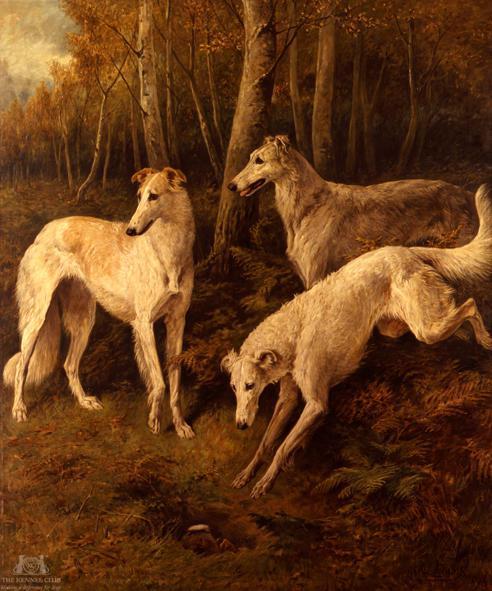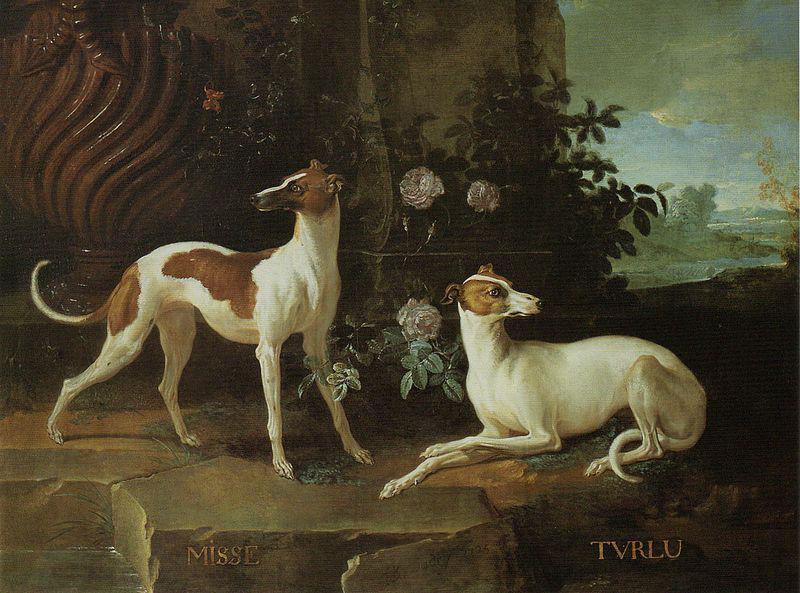The first image is the image on the left, the second image is the image on the right. For the images displayed, is the sentence "The dogs in the image on the right are outside." factually correct? Answer yes or no. Yes. The first image is the image on the left, the second image is the image on the right. Examine the images to the left and right. Is the description "An image includes a hound reclining on an animal skin." accurate? Answer yes or no. No. 